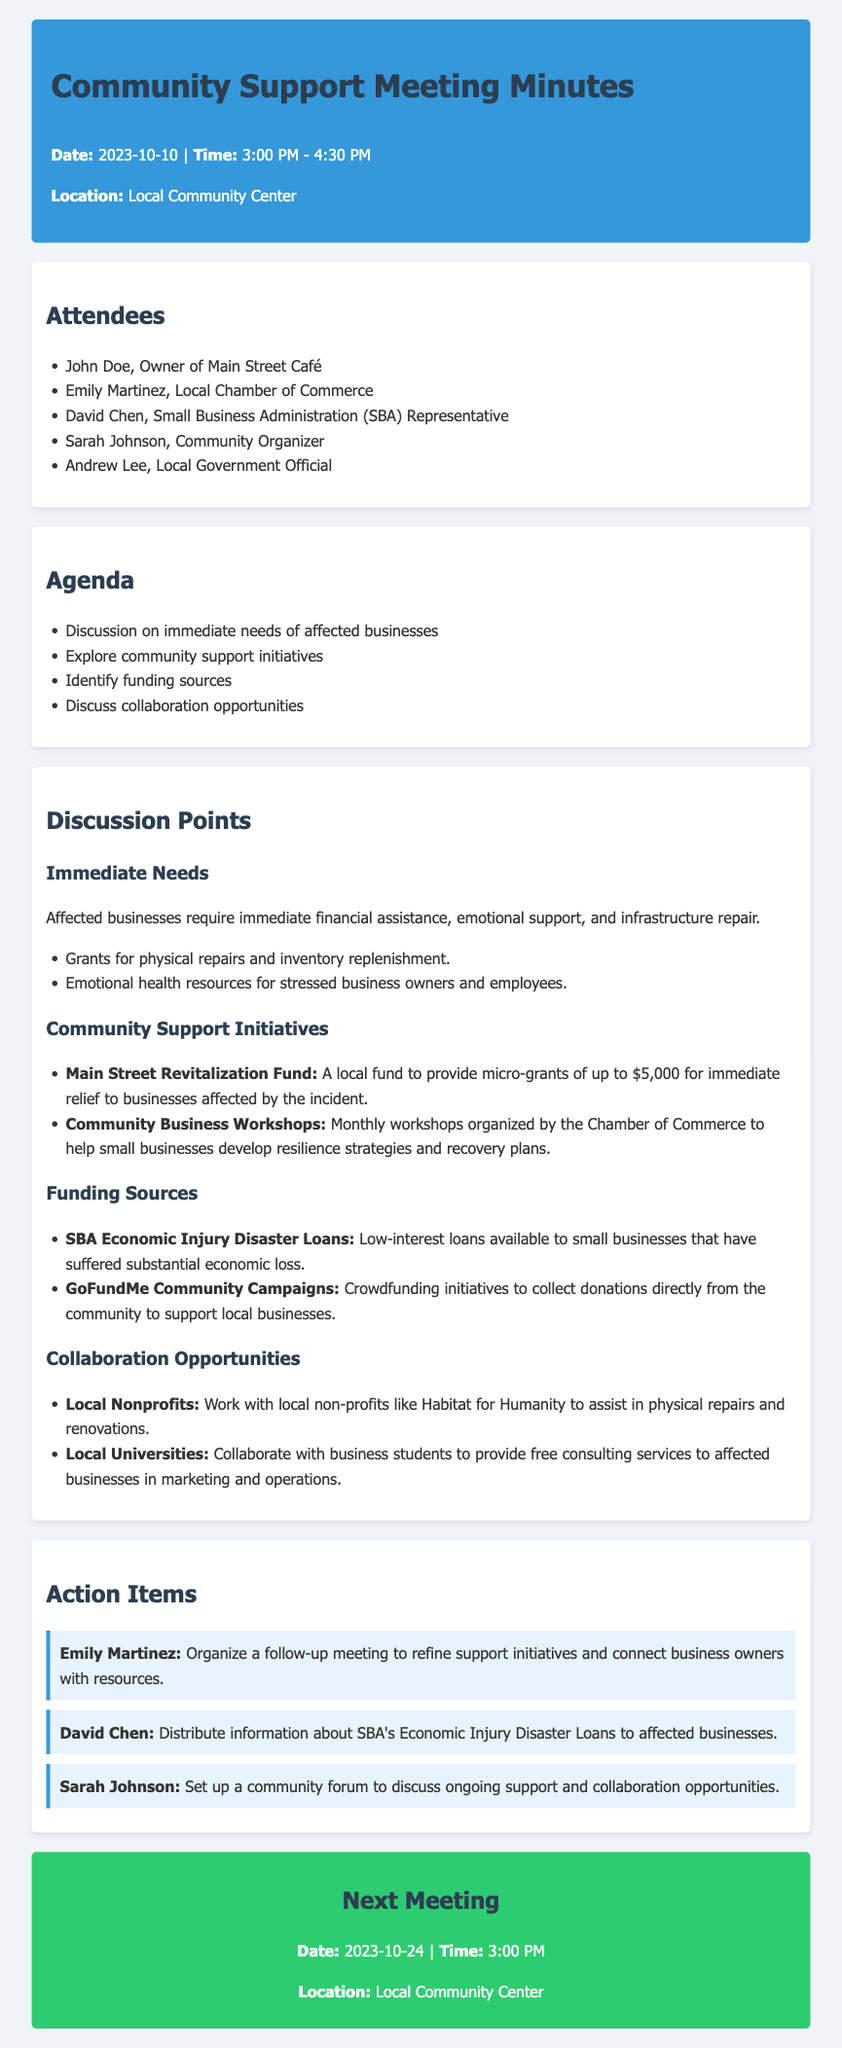What is the date of the meeting? The date of the meeting is mentioned in the header section, which states "2023-10-10."
Answer: 2023-10-10 Who is the owner of Main Street Café? The document lists attendees, and John Doe is mentioned as the owner of Main Street Café.
Answer: John Doe What is the maximum amount for micro-grants from the Main Street Revitalization Fund? The document states that the micro-grants provide up to $5,000 for immediate relief.
Answer: $5,000 What kind of loans are available through the SBA for affected businesses? The document specifies that the "SBA Economic Injury Disaster Loans" are available to small businesses that have suffered substantial economic loss.
Answer: Economic Injury Disaster Loans How frequently will the Community Business Workshops be held? The document indicates that these workshops will be organized on a monthly basis.
Answer: Monthly Who is responsible for organizing a follow-up meeting? The action items section names Emily Martinez as the person responsible for organizing a follow-up meeting.
Answer: Emily Martinez What is one collaboration opportunity mentioned for assistance with physical repairs? The document highlights working with local non-profits like Habitat for Humanity as a collaboration opportunity.
Answer: Habitat for Humanity When is the next meeting scheduled? The next meeting is scheduled as stated in the next meeting section of the document, which includes the date and time.
Answer: 2023-10-24 What type of consulting services will business students provide? The document mentions that local university business students will provide free consulting services in marketing and operations.
Answer: Marketing and operations 